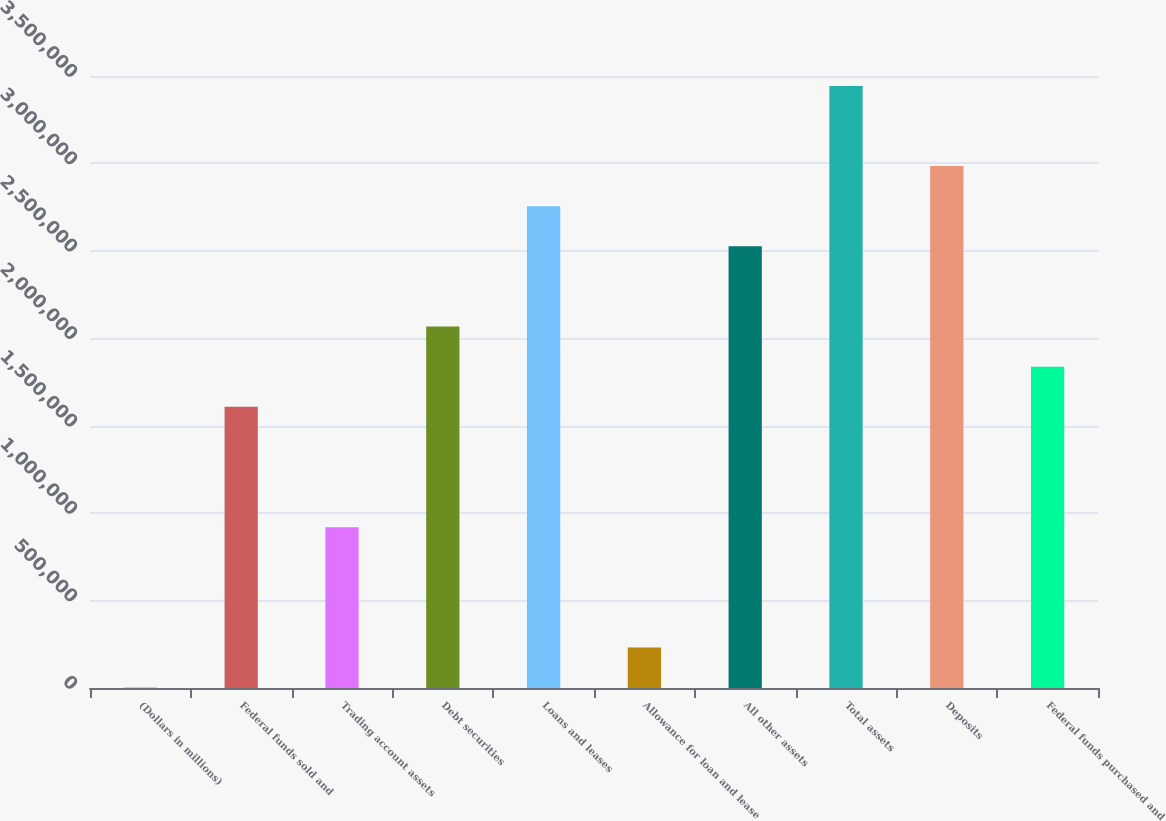Convert chart. <chart><loc_0><loc_0><loc_500><loc_500><bar_chart><fcel>(Dollars in millions)<fcel>Federal funds sold and<fcel>Trading account assets<fcel>Debt securities<fcel>Loans and leases<fcel>Allowance for loan and lease<fcel>All other assets<fcel>Total assets<fcel>Deposits<fcel>Federal funds purchased and<nl><fcel>2011<fcel>1.60803e+06<fcel>919735<fcel>2.06689e+06<fcel>2.75518e+06<fcel>231442<fcel>2.52575e+06<fcel>3.44348e+06<fcel>2.98462e+06<fcel>1.83746e+06<nl></chart> 